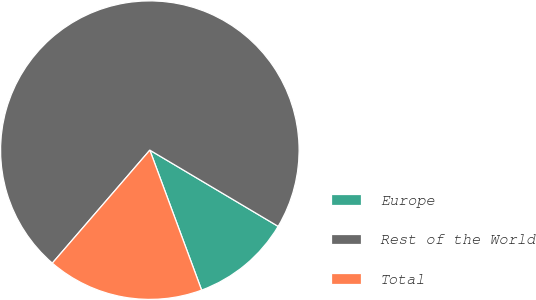Convert chart to OTSL. <chart><loc_0><loc_0><loc_500><loc_500><pie_chart><fcel>Europe<fcel>Rest of the World<fcel>Total<nl><fcel>10.83%<fcel>72.2%<fcel>16.97%<nl></chart> 